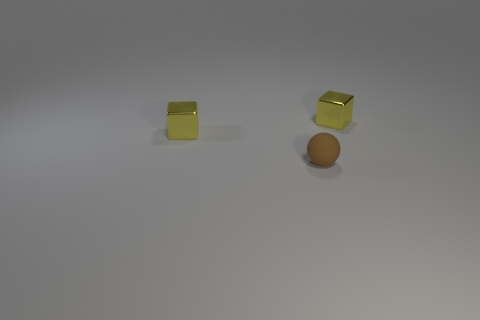What color are the two cubes and what is their arrangement relative to the sphere? The two cubes in the image are yellow, and they are arranged diagonally in relation to the brown sphere, with one cube on the left and one on the right. 